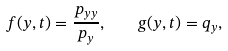Convert formula to latex. <formula><loc_0><loc_0><loc_500><loc_500>f ( y , t ) = \frac { p _ { y y } } { p _ { y } } , \quad g ( y , t ) = q _ { y } ,</formula> 